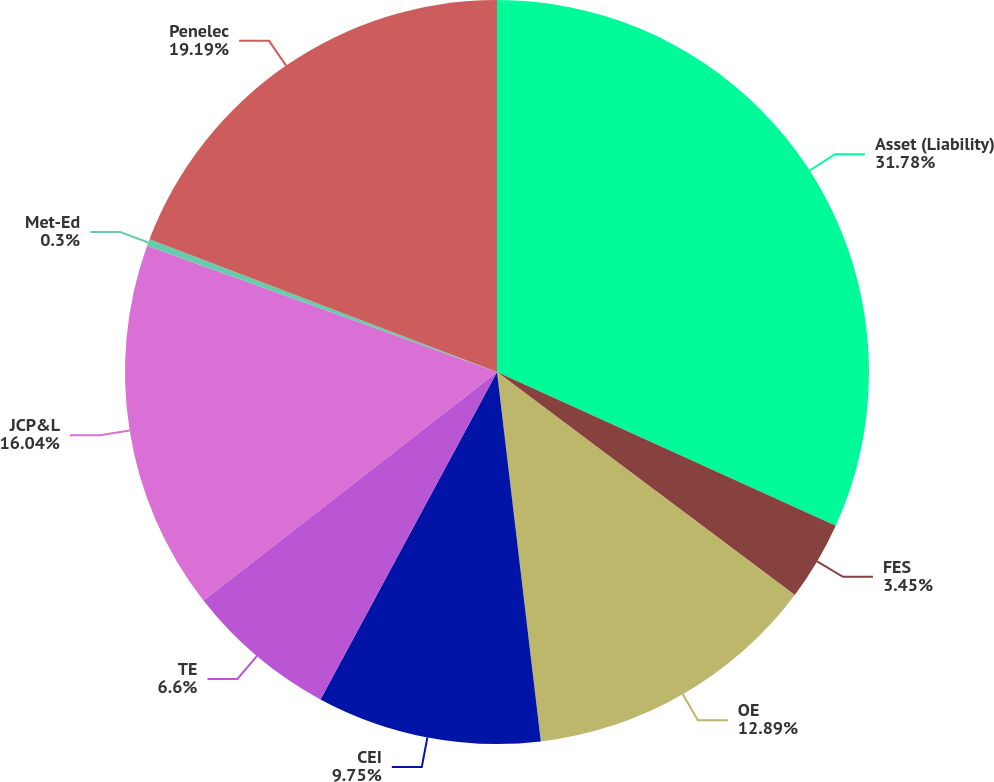Convert chart to OTSL. <chart><loc_0><loc_0><loc_500><loc_500><pie_chart><fcel>Asset (Liability)<fcel>FES<fcel>OE<fcel>CEI<fcel>TE<fcel>JCP&L<fcel>Met-Ed<fcel>Penelec<nl><fcel>31.78%<fcel>3.45%<fcel>12.89%<fcel>9.75%<fcel>6.6%<fcel>16.04%<fcel>0.3%<fcel>19.19%<nl></chart> 